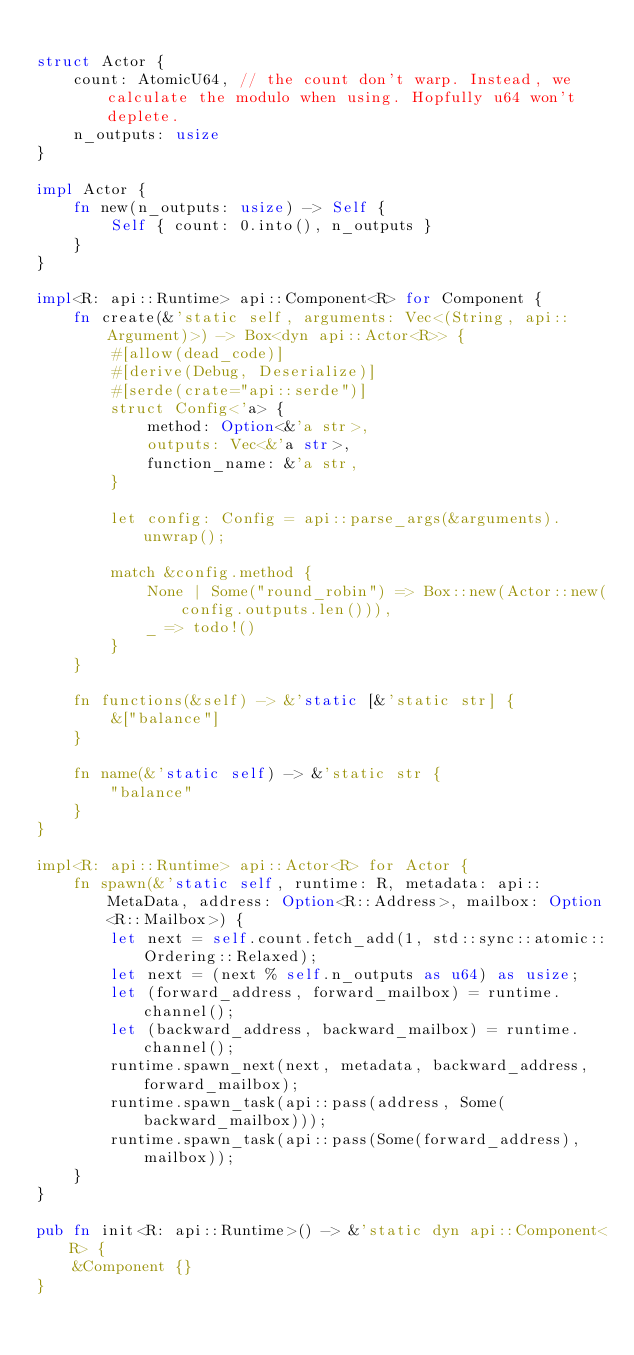Convert code to text. <code><loc_0><loc_0><loc_500><loc_500><_Rust_>
struct Actor {
    count: AtomicU64, // the count don't warp. Instead, we calculate the modulo when using. Hopfully u64 won't deplete.
    n_outputs: usize
}

impl Actor {
    fn new(n_outputs: usize) -> Self {
        Self { count: 0.into(), n_outputs }
    }
}

impl<R: api::Runtime> api::Component<R> for Component {
    fn create(&'static self, arguments: Vec<(String, api::Argument)>) -> Box<dyn api::Actor<R>> {
        #[allow(dead_code)]
        #[derive(Debug, Deserialize)]
        #[serde(crate="api::serde")]
        struct Config<'a> {
            method: Option<&'a str>,
            outputs: Vec<&'a str>,
            function_name: &'a str,
        }

        let config: Config = api::parse_args(&arguments).unwrap();

        match &config.method {
            None | Some("round_robin") => Box::new(Actor::new(config.outputs.len())),
            _ => todo!()
        }
    }

    fn functions(&self) -> &'static [&'static str] {
        &["balance"]
    }

    fn name(&'static self) -> &'static str {
        "balance"
    }
}

impl<R: api::Runtime> api::Actor<R> for Actor {
    fn spawn(&'static self, runtime: R, metadata: api::MetaData, address: Option<R::Address>, mailbox: Option<R::Mailbox>) {
        let next = self.count.fetch_add(1, std::sync::atomic::Ordering::Relaxed);
        let next = (next % self.n_outputs as u64) as usize;
        let (forward_address, forward_mailbox) = runtime.channel();
        let (backward_address, backward_mailbox) = runtime.channel();
        runtime.spawn_next(next, metadata, backward_address, forward_mailbox);
        runtime.spawn_task(api::pass(address, Some(backward_mailbox)));
        runtime.spawn_task(api::pass(Some(forward_address), mailbox));
    }
}

pub fn init<R: api::Runtime>() -> &'static dyn api::Component<R> {
    &Component {}
}
</code> 